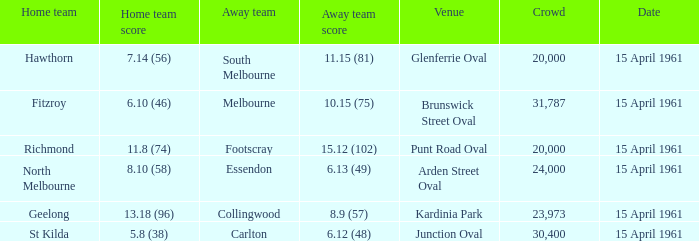Which site had a home team score of Brunswick Street Oval. 